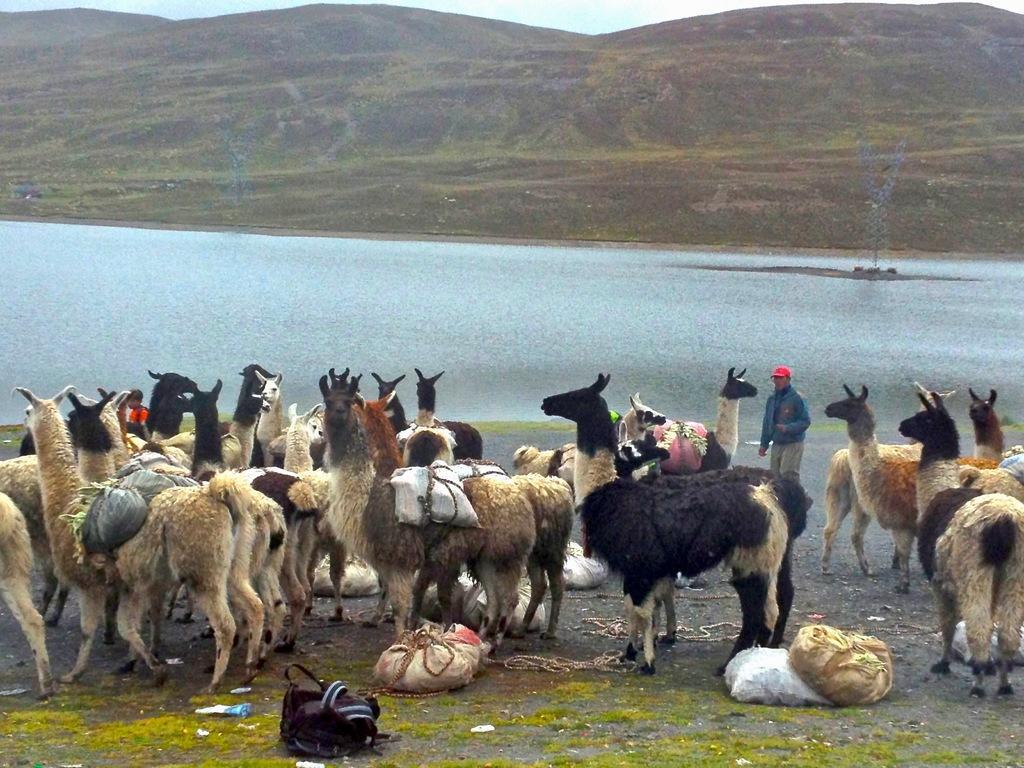How would you summarize this image in a sentence or two? In the image we can see there is herd of animals standing on the ground and they are carrying load at their back. There is a person standing and he is wearing red colour cap. Behind there is river and there are hills. 